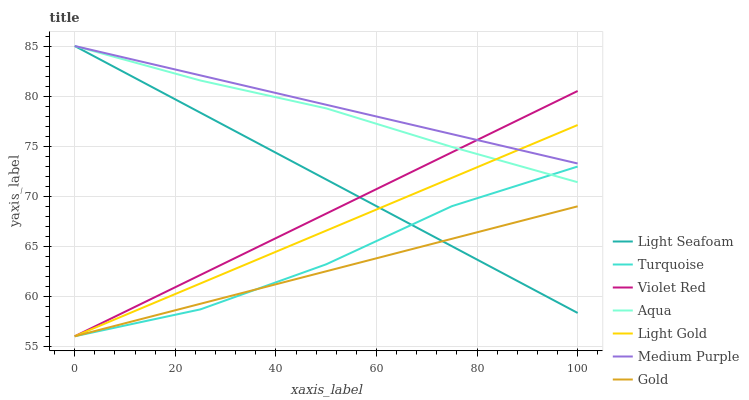Does Gold have the minimum area under the curve?
Answer yes or no. Yes. Does Medium Purple have the maximum area under the curve?
Answer yes or no. Yes. Does Aqua have the minimum area under the curve?
Answer yes or no. No. Does Aqua have the maximum area under the curve?
Answer yes or no. No. Is Medium Purple the smoothest?
Answer yes or no. Yes. Is Turquoise the roughest?
Answer yes or no. Yes. Is Gold the smoothest?
Answer yes or no. No. Is Gold the roughest?
Answer yes or no. No. Does Turquoise have the lowest value?
Answer yes or no. Yes. Does Aqua have the lowest value?
Answer yes or no. No. Does Light Seafoam have the highest value?
Answer yes or no. Yes. Does Gold have the highest value?
Answer yes or no. No. Is Gold less than Aqua?
Answer yes or no. Yes. Is Aqua greater than Gold?
Answer yes or no. Yes. Does Light Gold intersect Light Seafoam?
Answer yes or no. Yes. Is Light Gold less than Light Seafoam?
Answer yes or no. No. Is Light Gold greater than Light Seafoam?
Answer yes or no. No. Does Gold intersect Aqua?
Answer yes or no. No. 